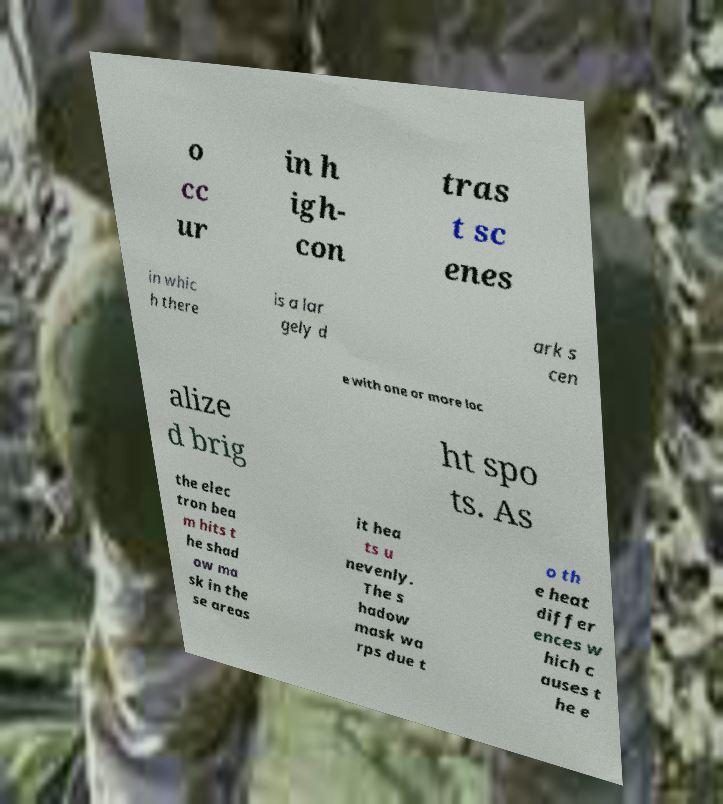There's text embedded in this image that I need extracted. Can you transcribe it verbatim? o cc ur in h igh- con tras t sc enes in whic h there is a lar gely d ark s cen e with one or more loc alize d brig ht spo ts. As the elec tron bea m hits t he shad ow ma sk in the se areas it hea ts u nevenly. The s hadow mask wa rps due t o th e heat differ ences w hich c auses t he e 